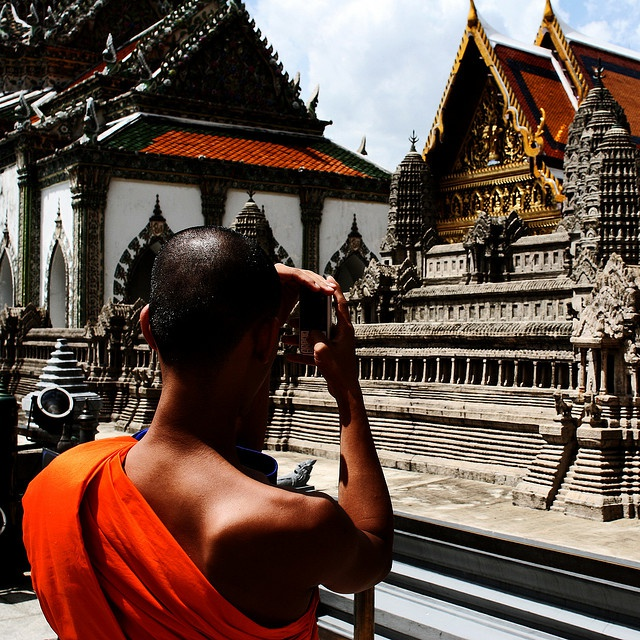Describe the objects in this image and their specific colors. I can see people in black, maroon, and red tones and cell phone in black, maroon, and brown tones in this image. 